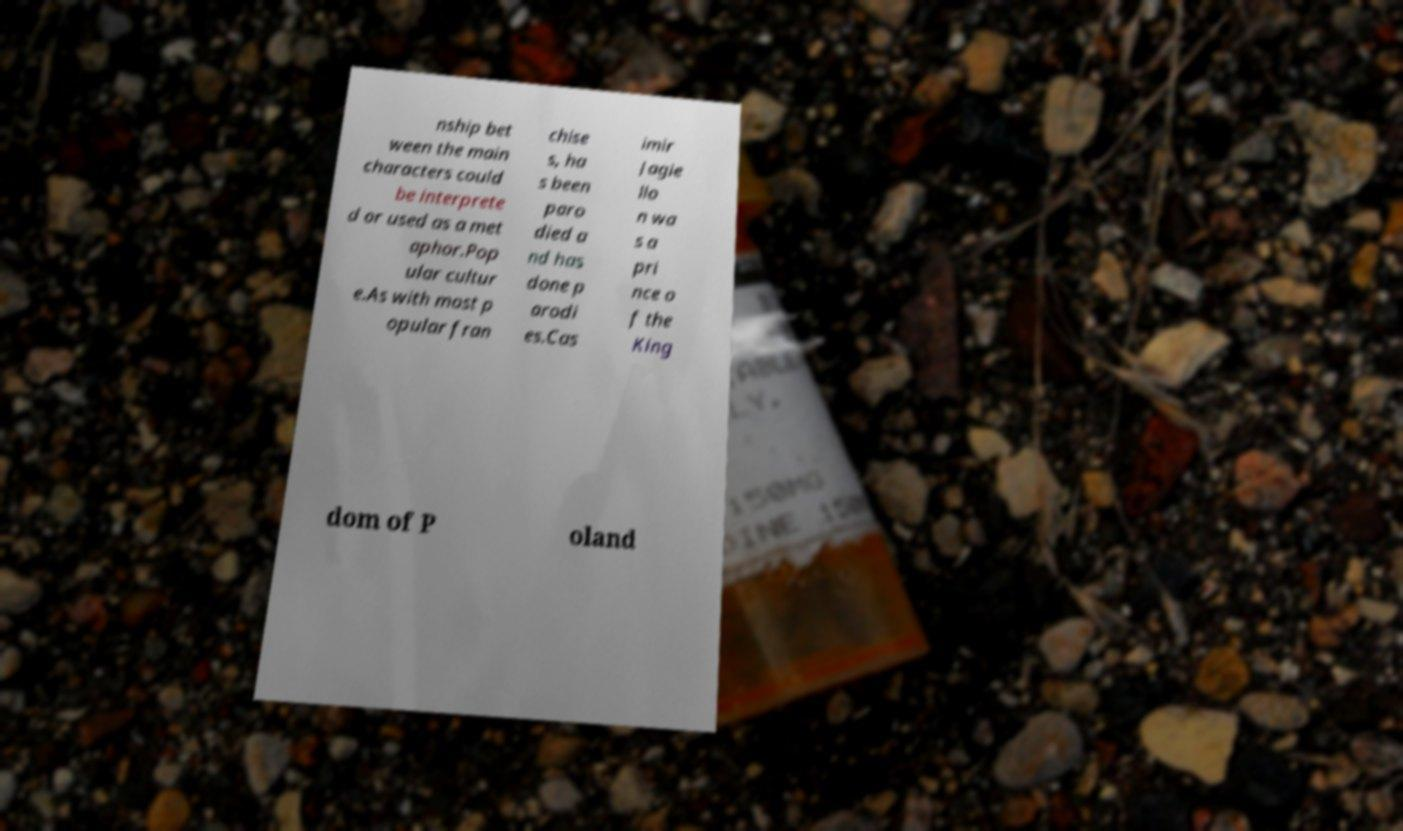Please identify and transcribe the text found in this image. nship bet ween the main characters could be interprete d or used as a met aphor.Pop ular cultur e.As with most p opular fran chise s, ha s been paro died a nd has done p arodi es.Cas imir Jagie llo n wa s a pri nce o f the King dom of P oland 